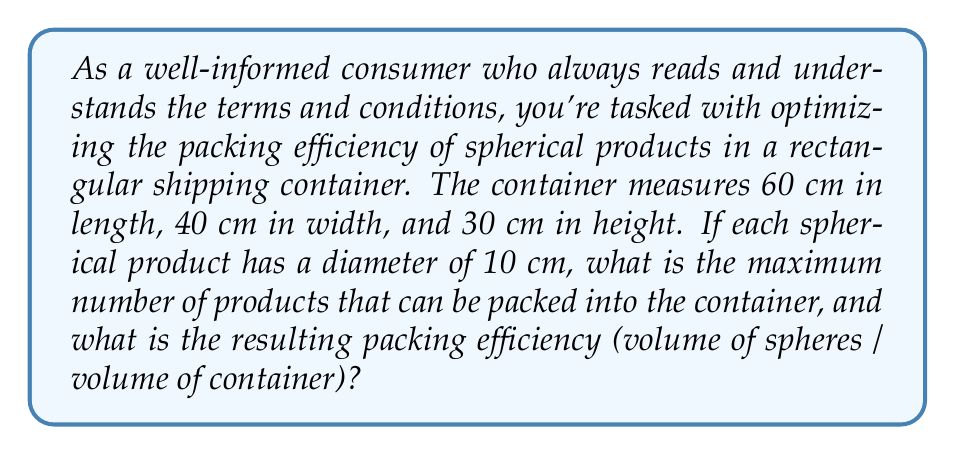What is the answer to this math problem? To solve this problem, we'll follow these steps:

1) First, let's determine how many spheres can fit along each dimension of the container:
   Length: 60 cm ÷ 10 cm = 6 spheres
   Width: 40 cm ÷ 10 cm = 4 spheres
   Height: 30 cm ÷ 10 cm = 3 spheres

2) The most efficient packing arrangement for spheres is called "close packing". In this arrangement, each layer forms a hexagonal lattice, and alternate layers are offset.

3) In a single layer, we can fit:
   $$(6 \times 4) - (3 \times 1) = 21$$ spheres
   (We subtract 3 because every other row loses one sphere due to the offset)

4) We can fit 3 such layers in the container, so the total number of spheres is:
   $$21 \times 3 = 63$$ spheres

5) Now, let's calculate the packing efficiency:
   
   Volume of container: $$V_c = 60 \times 40 \times 30 = 72,000$$ cm³
   
   Volume of a single sphere: $$V_s = \frac{4}{3}\pi r^3 = \frac{4}{3}\pi 5^3 \approx 523.6$$ cm³
   
   Total volume of spheres: $$63 \times 523.6 = 32,986.8$$ cm³
   
   Packing efficiency: $$\frac{32,986.8}{72,000} \times 100\% \approx 45.81\%$$

This packing efficiency is close to the theoretical maximum of about 74% for random close packing of equal spheres, considering the constraints of the rectangular container.
Answer: The maximum number of spherical products that can be packed into the container is 63, and the resulting packing efficiency is approximately 45.81%. 